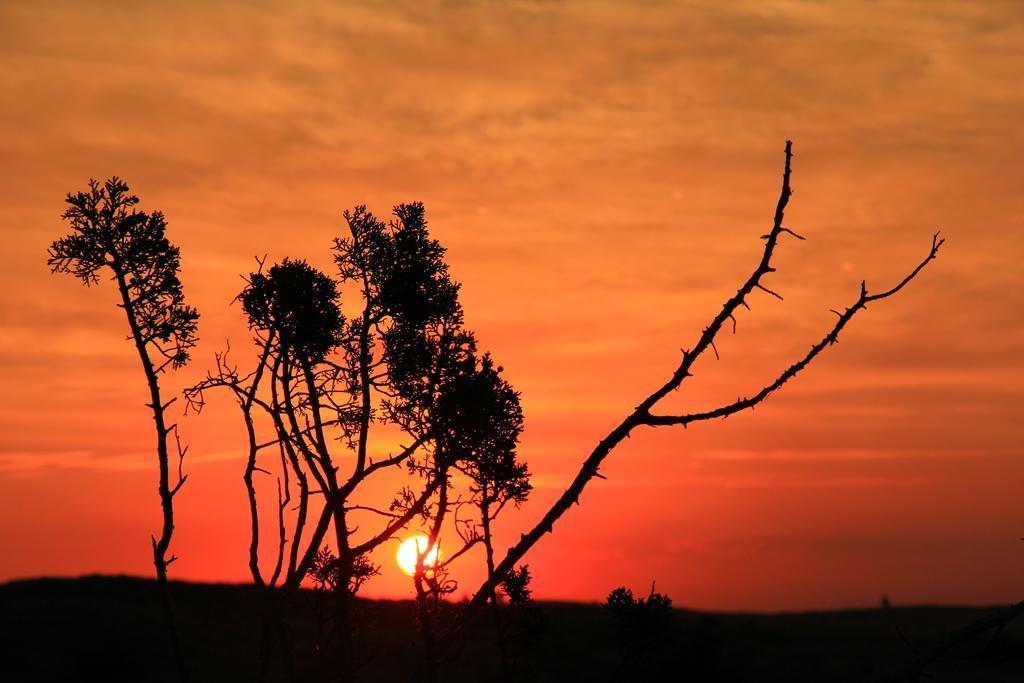What is the weather like in the image? The sky is cloudy in the image. What type of vegetation can be seen in the image? There are trees visible in the image. Can the sun be seen in the image? Yes, the sun is visible in the distance. What type of linen is being distributed in the room in the image? There is no room or linen present in the image; it only features a cloudy sky and trees. 